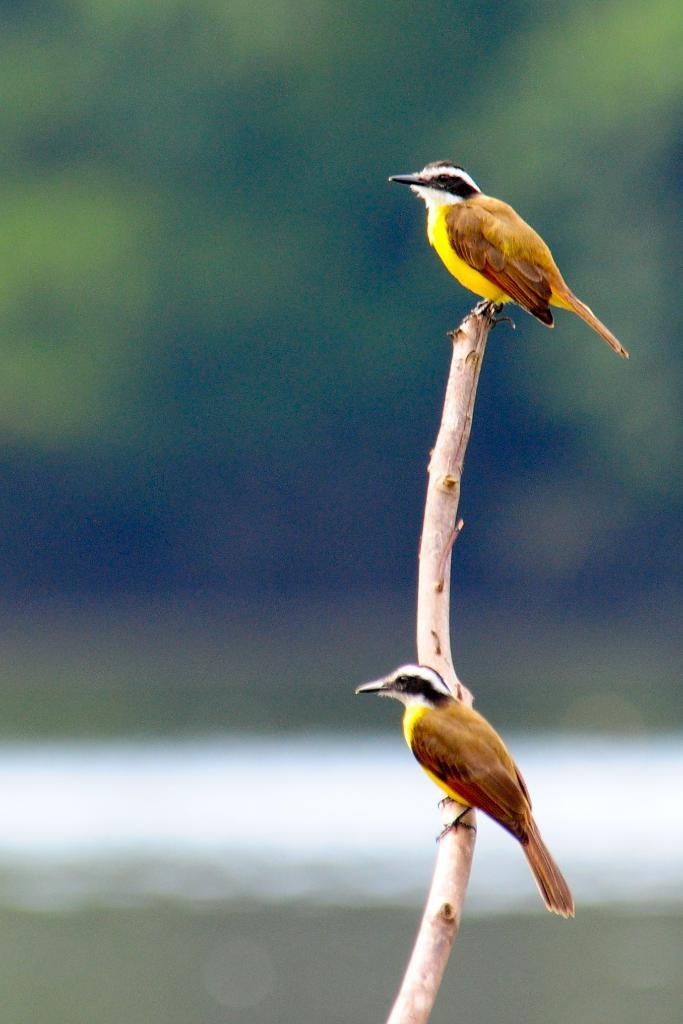How many birds are present in the image? There are two birds in the image. What are the birds positioned on? The birds are on a stick. Can you describe the background of the image? The background of the image is blurred. What type of quilt is being used to support the birds in the image? There is no quilt present in the image; the birds are on a stick. Can you tell me how many beams are visible in the image? There are no beams visible in the image; it only features two birds on a stick with a blurred background. 